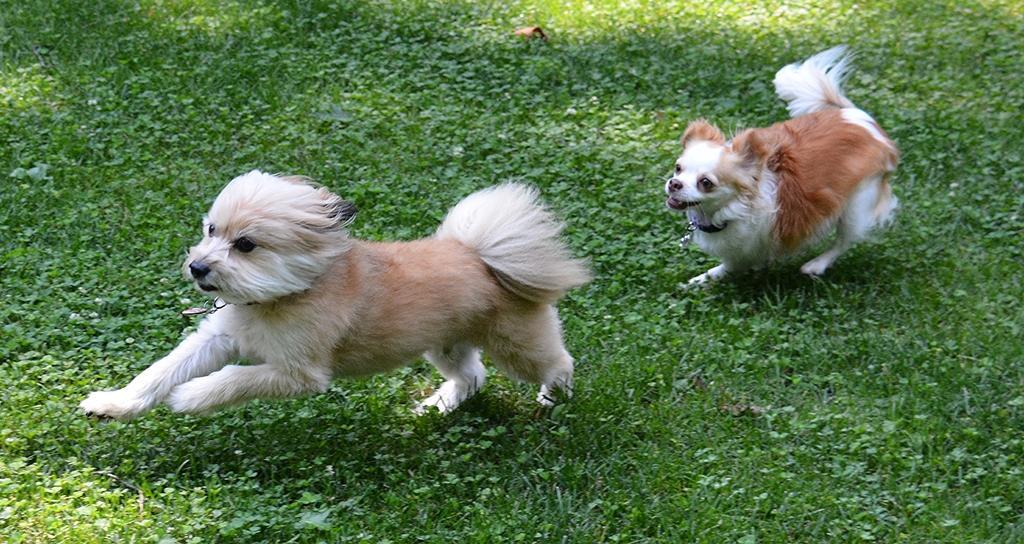Describe this image in one or two sentences. In the picture we can see two dogs on the ground, there is grass on the ground. 